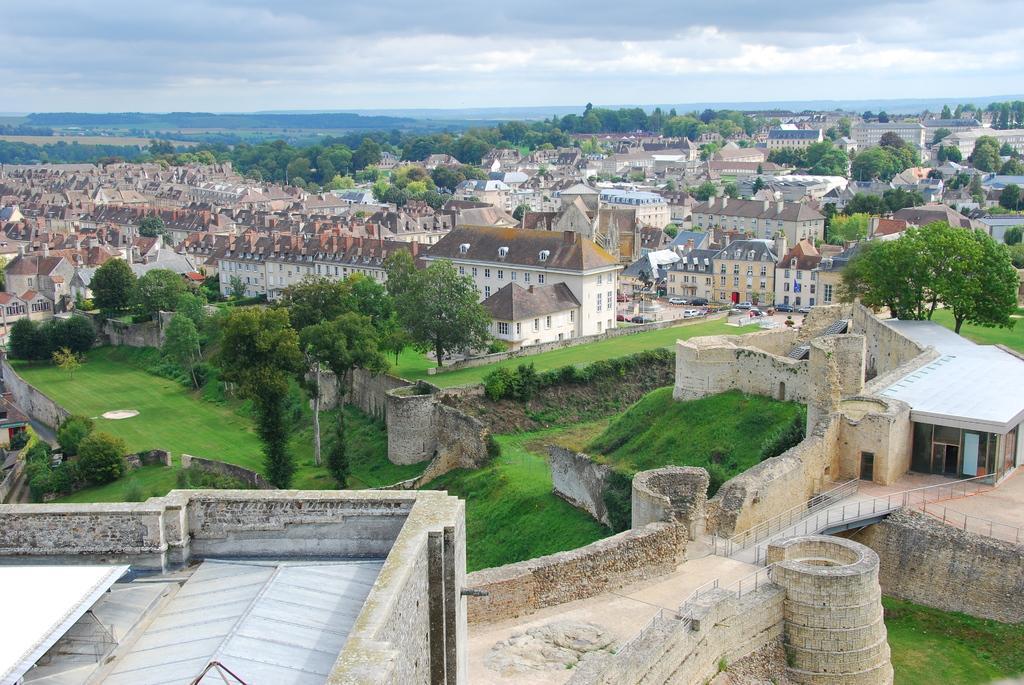Describe this image in one or two sentences. In this image I can see number of buildings and in between the buildings there are trees and plants. In the background there is sky 